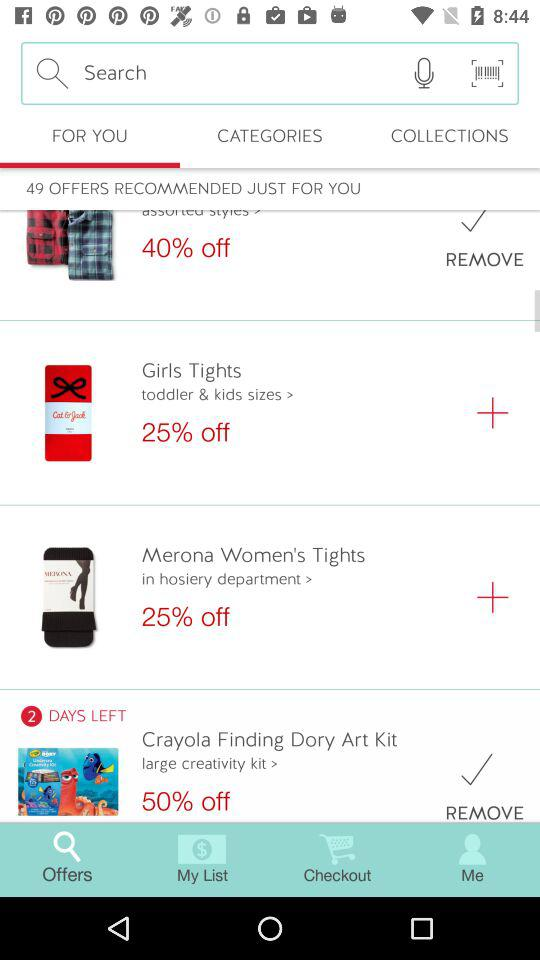How much is a discount on "Crayola Finding Dory Art Kit"? There is a 50% discount. 